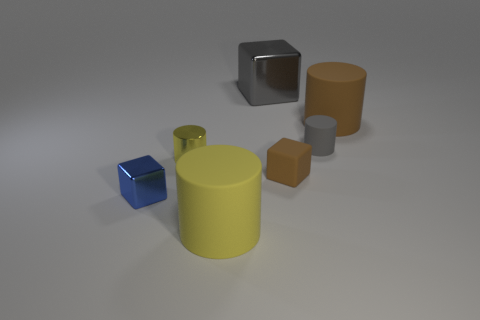Do the big block and the tiny matte cylinder have the same color?
Offer a very short reply. Yes. Are there more small metallic cylinders than tiny rubber objects?
Your answer should be compact. No. How many other objects are the same material as the brown cylinder?
Your answer should be very brief. 3. How many things are either brown shiny blocks or cylinders behind the small yellow object?
Ensure brevity in your answer.  2. Is the number of small gray shiny objects less than the number of small gray objects?
Make the answer very short. Yes. What is the color of the tiny block right of the yellow cylinder that is right of the yellow object behind the tiny blue block?
Keep it short and to the point. Brown. Do the big block and the tiny blue object have the same material?
Provide a succinct answer. Yes. How many cylinders are right of the tiny brown cube?
Provide a short and direct response. 2. There is a gray thing that is the same shape as the yellow shiny object; what is its size?
Provide a short and direct response. Small. What number of blue objects are either small metallic cubes or small cubes?
Provide a succinct answer. 1. 